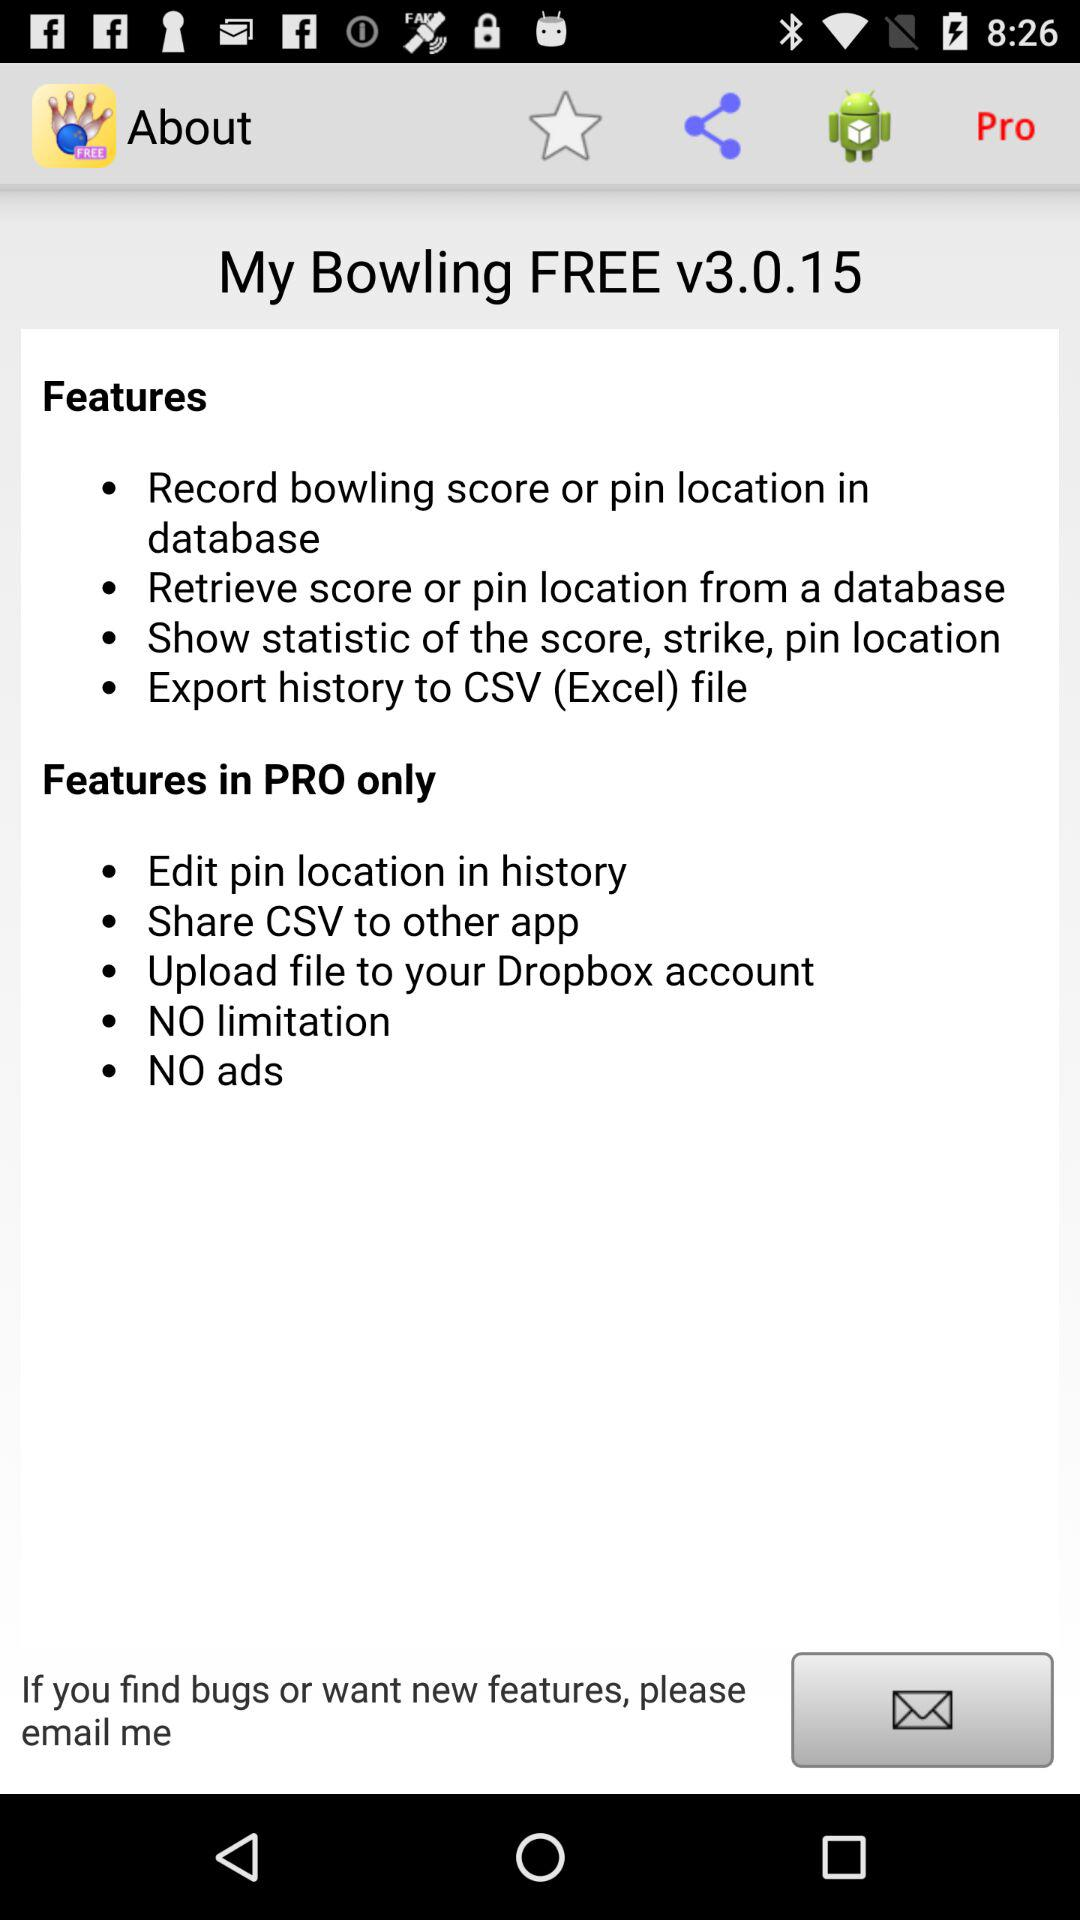What is the version of the application? The version is v3.0.15. 